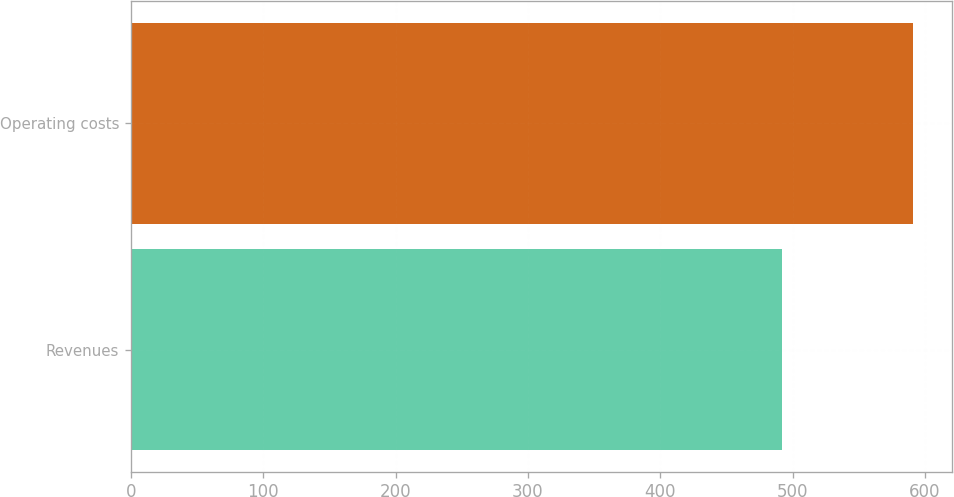<chart> <loc_0><loc_0><loc_500><loc_500><bar_chart><fcel>Revenues<fcel>Operating costs<nl><fcel>492<fcel>591<nl></chart> 